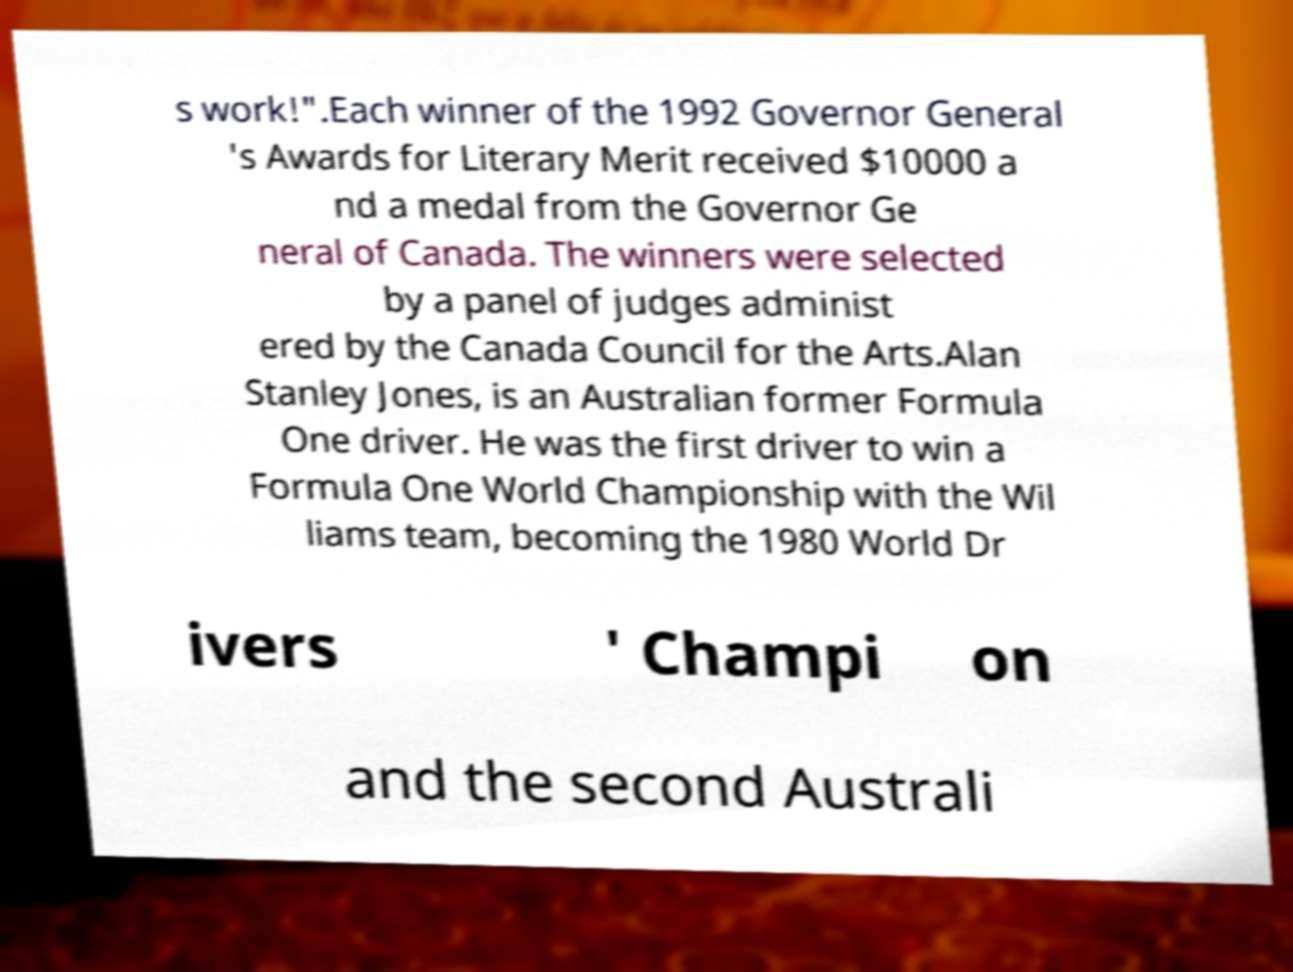Can you read and provide the text displayed in the image?This photo seems to have some interesting text. Can you extract and type it out for me? s work!".Each winner of the 1992 Governor General 's Awards for Literary Merit received $10000 a nd a medal from the Governor Ge neral of Canada. The winners were selected by a panel of judges administ ered by the Canada Council for the Arts.Alan Stanley Jones, is an Australian former Formula One driver. He was the first driver to win a Formula One World Championship with the Wil liams team, becoming the 1980 World Dr ivers ' Champi on and the second Australi 